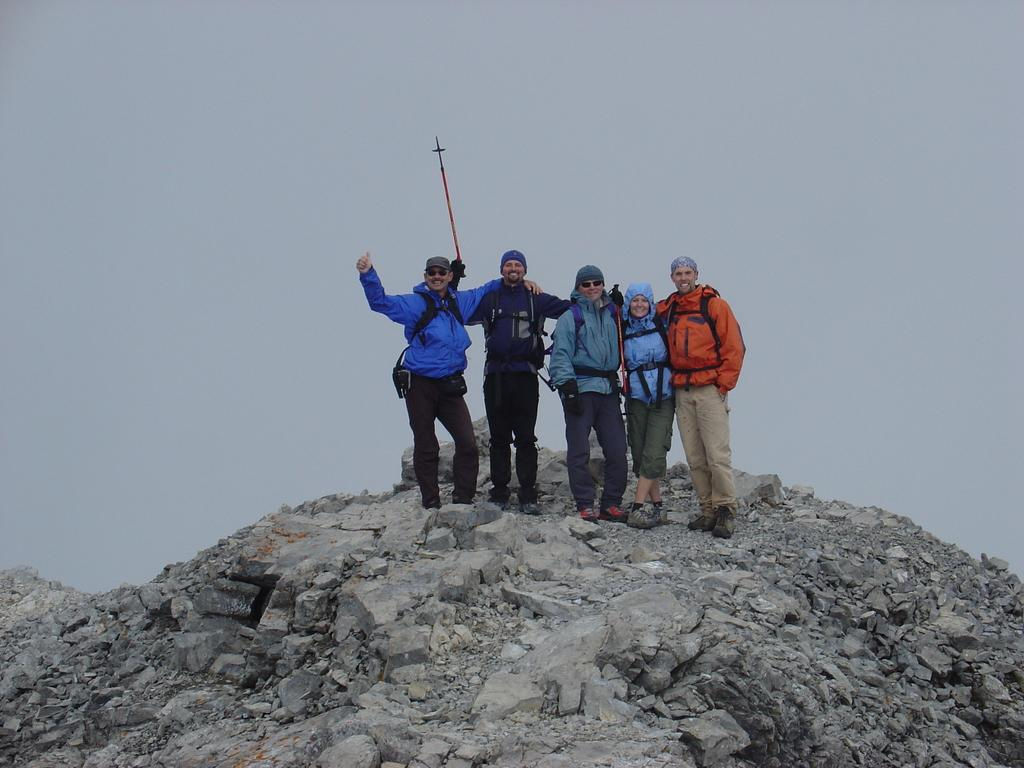How many people are in the image? There are five persons in the image. What type of clothing are the persons wearing? The persons are wearing jackets, pants, and caps. Where are the persons standing in the image? The persons are standing on a rock mountain. What is the color of the rock mountain? The rock mountain is black and ash in color. What can be seen in the background of the image? The sky is visible in the background of the image. Can you see a locket hanging from any of the persons' necks in the image? There is no mention of a locket in the provided facts, so it cannot be determined if one is present in the image. 